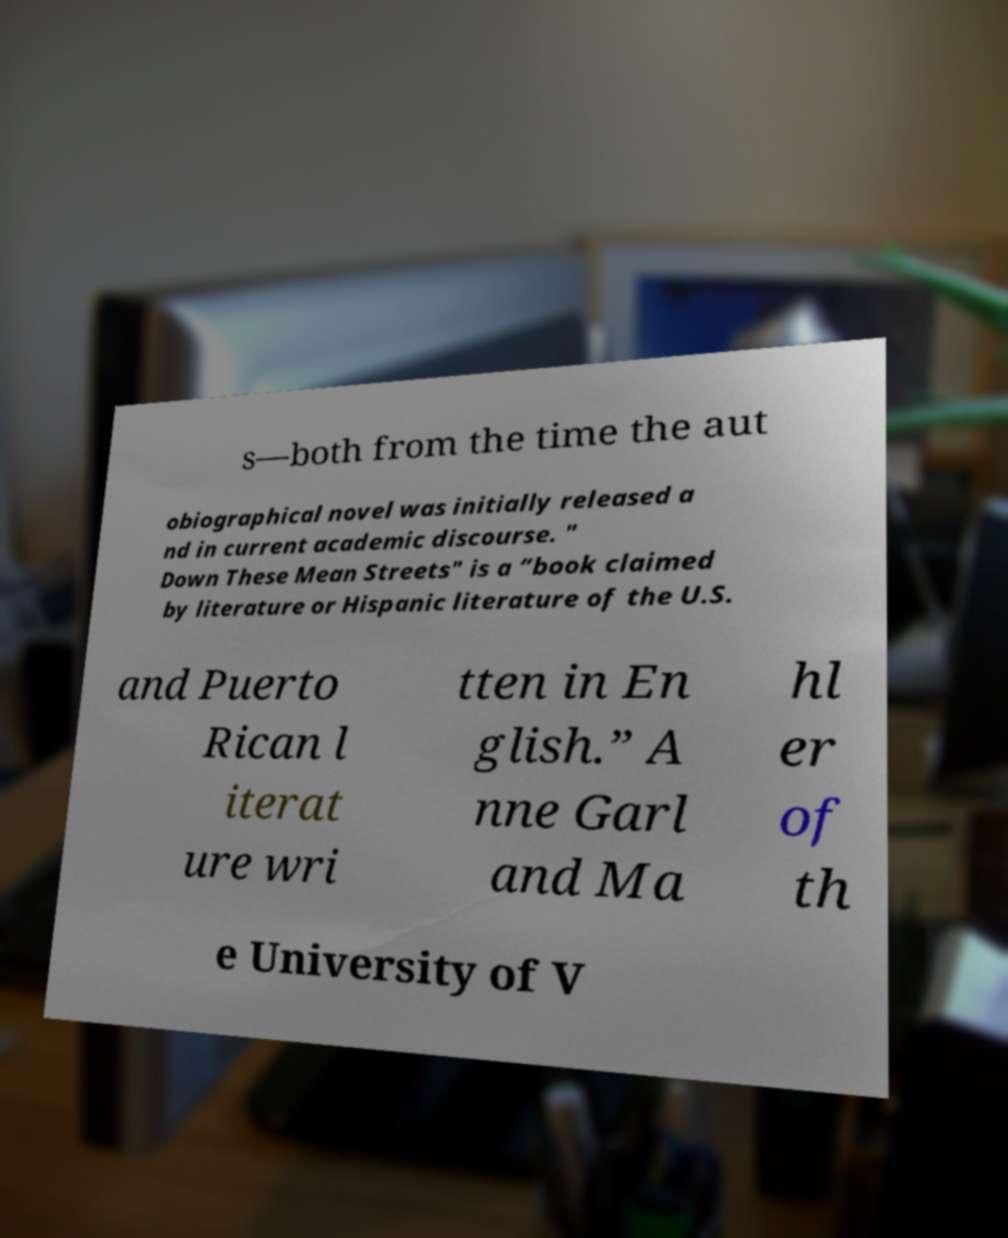Please identify and transcribe the text found in this image. s—both from the time the aut obiographical novel was initially released a nd in current academic discourse. " Down These Mean Streets" is a “book claimed by literature or Hispanic literature of the U.S. and Puerto Rican l iterat ure wri tten in En glish.” A nne Garl and Ma hl er of th e University of V 